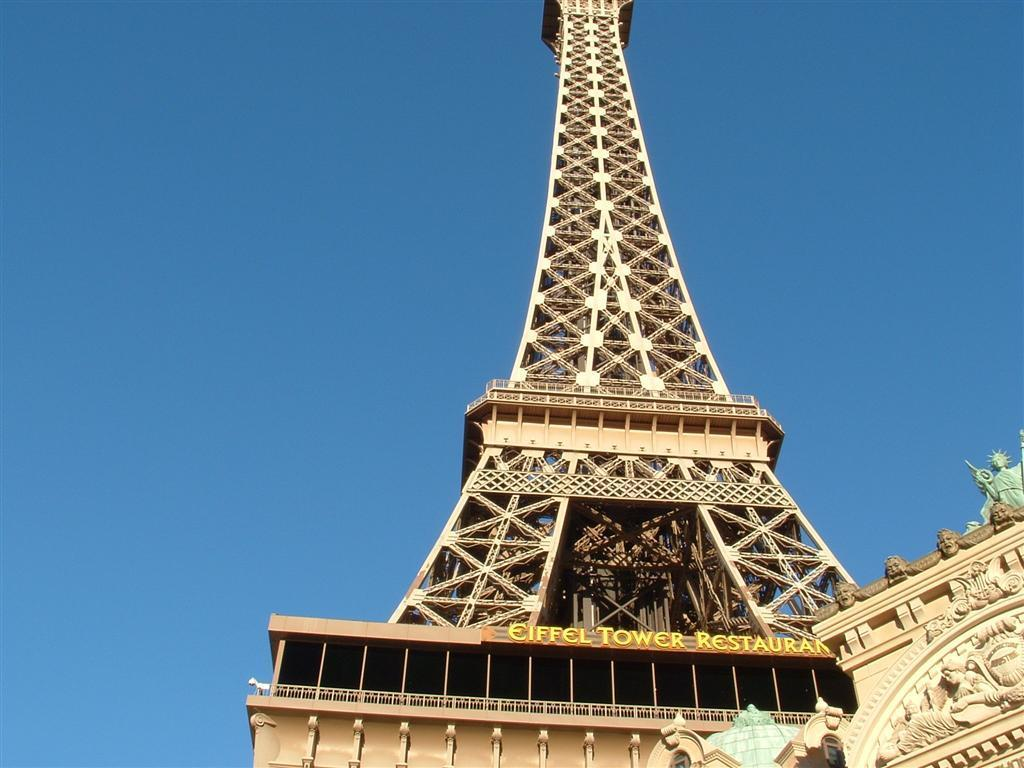What is the main subject of the image? The main subject of the image is a restaurant at the Eiffel tower. Can you describe the surroundings of the restaurant? There is another building beside the Eiffel tower restaurant in the image. Is there any snow visible in the image? There is no mention of snow in the provided facts, and therefore it cannot be determined if snow is present in the image. 